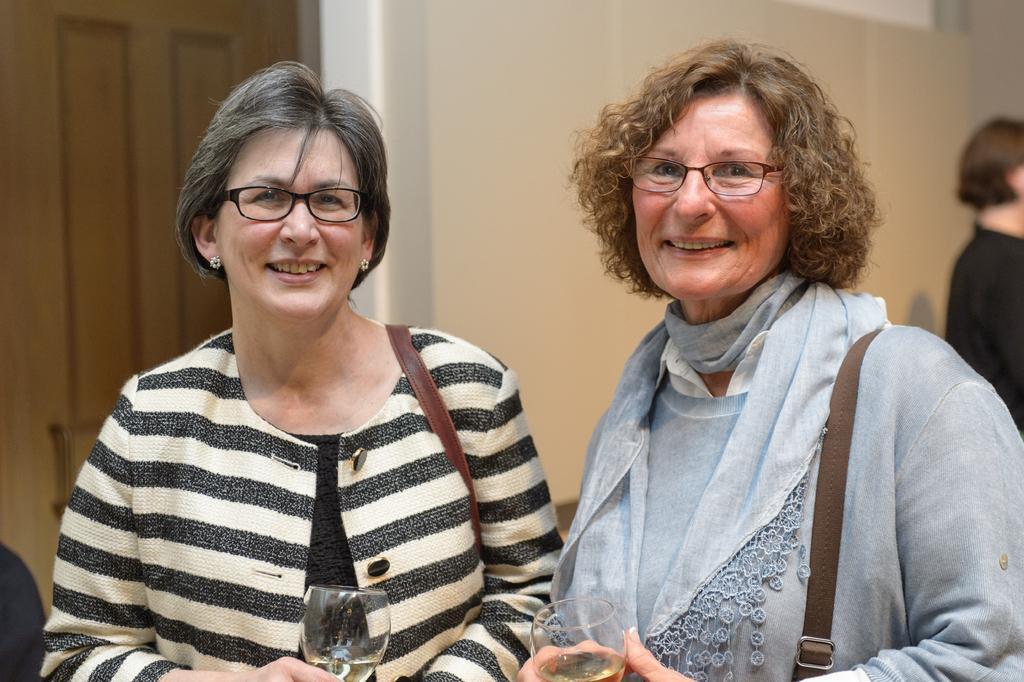In one or two sentences, can you explain what this image depicts? In this image we can see two ladies wearing handbags, holding glasses with wine in it, and behind the, there is wall, and a door. 